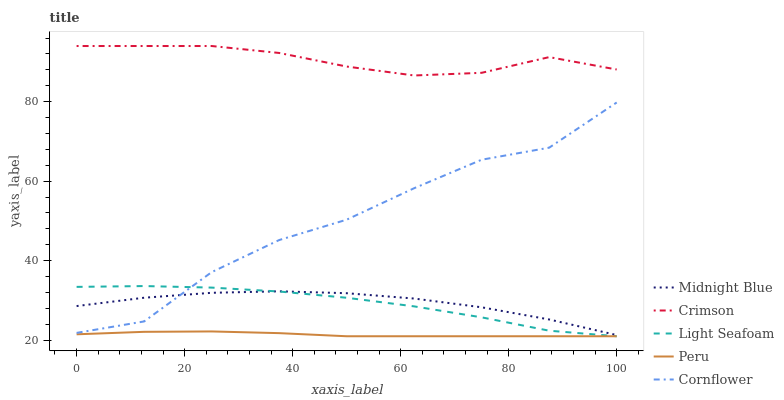Does Peru have the minimum area under the curve?
Answer yes or no. Yes. Does Crimson have the maximum area under the curve?
Answer yes or no. Yes. Does Cornflower have the minimum area under the curve?
Answer yes or no. No. Does Cornflower have the maximum area under the curve?
Answer yes or no. No. Is Peru the smoothest?
Answer yes or no. Yes. Is Cornflower the roughest?
Answer yes or no. Yes. Is Light Seafoam the smoothest?
Answer yes or no. No. Is Light Seafoam the roughest?
Answer yes or no. No. Does Light Seafoam have the lowest value?
Answer yes or no. Yes. Does Cornflower have the lowest value?
Answer yes or no. No. Does Crimson have the highest value?
Answer yes or no. Yes. Does Cornflower have the highest value?
Answer yes or no. No. Is Midnight Blue less than Crimson?
Answer yes or no. Yes. Is Crimson greater than Peru?
Answer yes or no. Yes. Does Peru intersect Light Seafoam?
Answer yes or no. Yes. Is Peru less than Light Seafoam?
Answer yes or no. No. Is Peru greater than Light Seafoam?
Answer yes or no. No. Does Midnight Blue intersect Crimson?
Answer yes or no. No. 